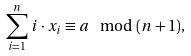<formula> <loc_0><loc_0><loc_500><loc_500>\sum _ { i = 1 } ^ { n } \, i \cdot x _ { i } \equiv a \mod ( n + 1 ) ,</formula> 